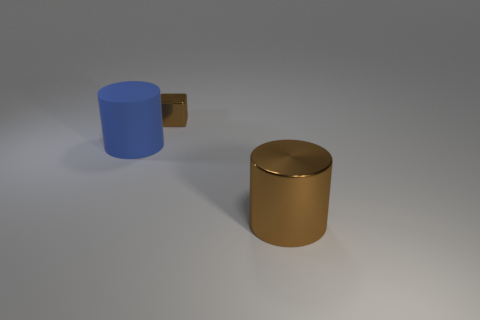Add 2 large gray rubber balls. How many objects exist? 5 Add 2 cubes. How many cubes are left? 3 Add 1 small green metallic objects. How many small green metallic objects exist? 1 Subtract all blue cylinders. How many cylinders are left? 1 Subtract 0 cyan spheres. How many objects are left? 3 Subtract all cylinders. How many objects are left? 1 Subtract 1 cylinders. How many cylinders are left? 1 Subtract all cyan blocks. Subtract all cyan balls. How many blocks are left? 1 Subtract all cyan balls. How many brown cylinders are left? 1 Subtract all blue rubber cubes. Subtract all big metallic cylinders. How many objects are left? 2 